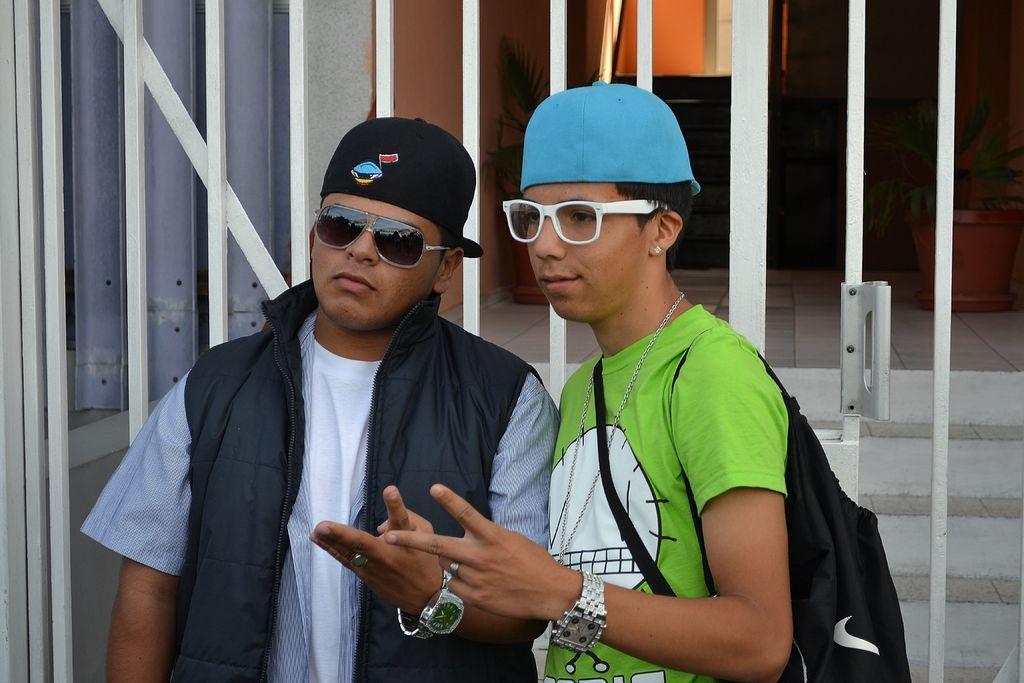Please provide a concise description of this image. In this picture I can observe two men wearing spectacles and caps on their heads. Behind them there is a white color gate. 